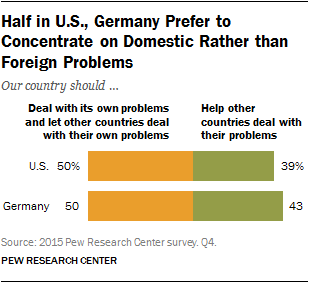Draw attention to some important aspects in this diagram. The leftmost color of each bar is orange. The average response from those who believe that both Germany and the US should help other countries deal with their problems is 0.41. 